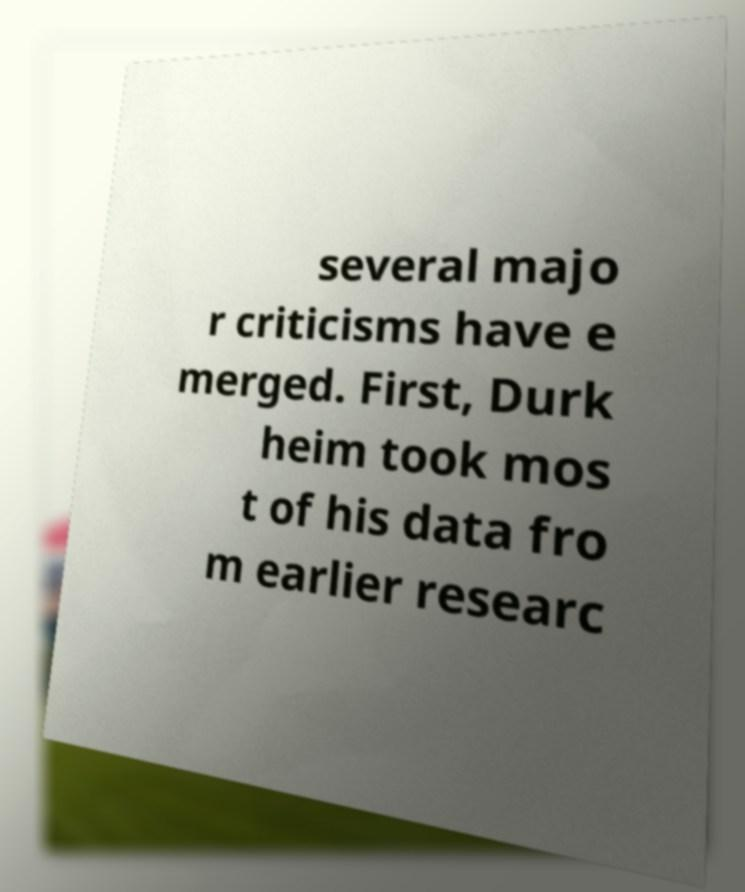I need the written content from this picture converted into text. Can you do that? several majo r criticisms have e merged. First, Durk heim took mos t of his data fro m earlier researc 